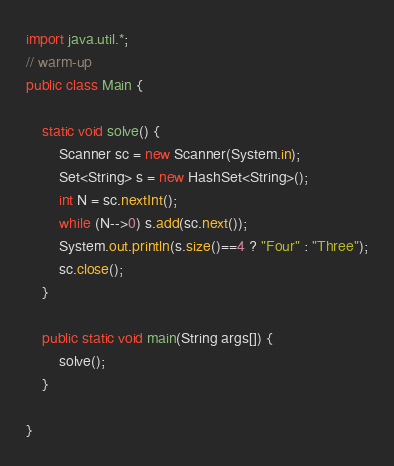<code> <loc_0><loc_0><loc_500><loc_500><_Java_>import java.util.*;
// warm-up
public class Main {

	static void solve() {
		Scanner sc = new Scanner(System.in);
		Set<String> s = new HashSet<String>();
		int N = sc.nextInt();
		while (N-->0) s.add(sc.next());
		System.out.println(s.size()==4 ? "Four" : "Three");
		sc.close();		
	}

	public static void main(String args[]) {
		solve();
	}

}</code> 